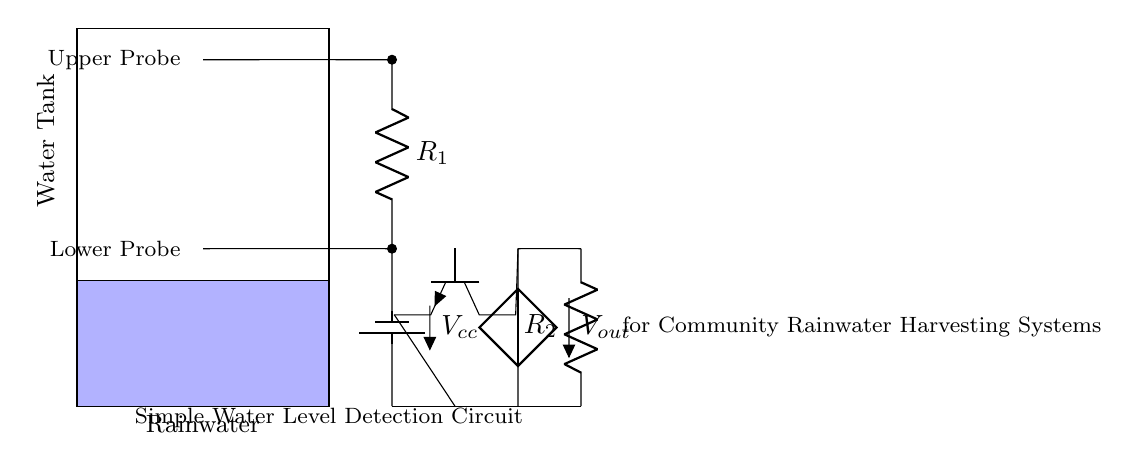What does the blue area represent? The blue area represents the water level in the tank, indicating the space filled with water. The diagram clearly delineates the tank structure and uses color to differentiate between the water and the tank itself.
Answer: Water level What is the purpose of the upper probe? The upper probe detects the maximum water level in the tank. When the water reaches this height, the circuit indicates that the tank is full, preventing overflow. This functionality is crucial for managing rainwater harvesting effectively.
Answer: Maximum water level detection What are the resistance values present in this circuit? The circuit includes two resistors labeled as R1 and R2. Each resistor is crucial for limiting current flow and creating the appropriate voltage levels at specific points in the circuit, although their exact values are not given in the diagram.
Answer: R1 and R2 What type of transistor is used in this circuit? The circuit utilizes an NPN transistor, which is indicated by the labeling. This type of transistor is commonly used for switching and amplification in electronic circuits and plays a vital role in the operation of the water level detection mechanism.
Answer: NPN How does the circuit determine if the water is at a low level? The circuit measures the voltage difference created by the resistors in conjunction with the input from the probes. When the water drops below the lower probe, the circuit will trigger an output signal, indicating low water levels and thus allowing for prompt action to be taken.
Answer: By measuring voltage What role does the battery play in the circuit? The battery provides the necessary voltage, labeled as Vcc, powering the circuit to enable the operation of components like resistors and the transistor. It is essential for maintaining circuit functionality and signal integrity.
Answer: Provides voltage What happens when the water reaches the upper probe? When the water level reaches the upper probe, the circuit is designed to trigger a response, such as turning off a pump or activating an alarm. This function prevents overflow and maintains efficient rainwater harvesting.
Answer: Triggers response 